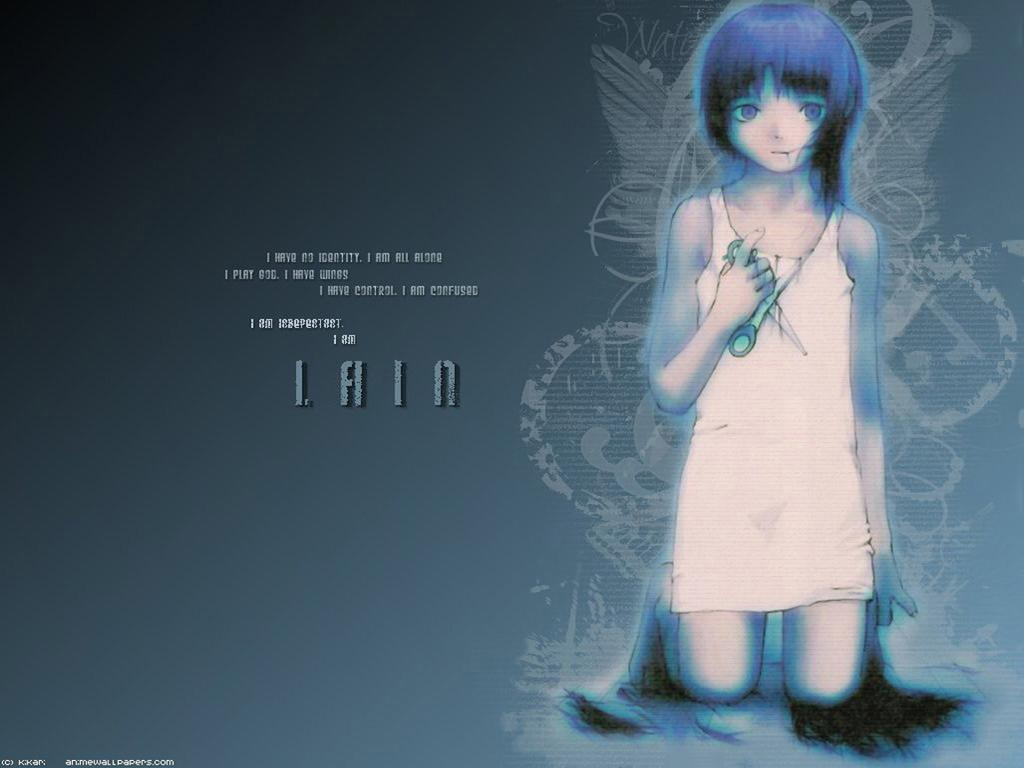What is the girl in the image wearing? The girl in the image is wearing a white dress. What is the girl holding in her hand? The girl is holding scissors in her hand. What colors are present in the girl's hair? The girl's hair is blue and black in color. What type of celery is the girl eating in the image? There is no celery present in the image; the girl is holding scissors. How many friends is the girl talking to in the image? There is no indication of friends or a conversation in the image; the girl is holding scissors and wearing a white dress. 